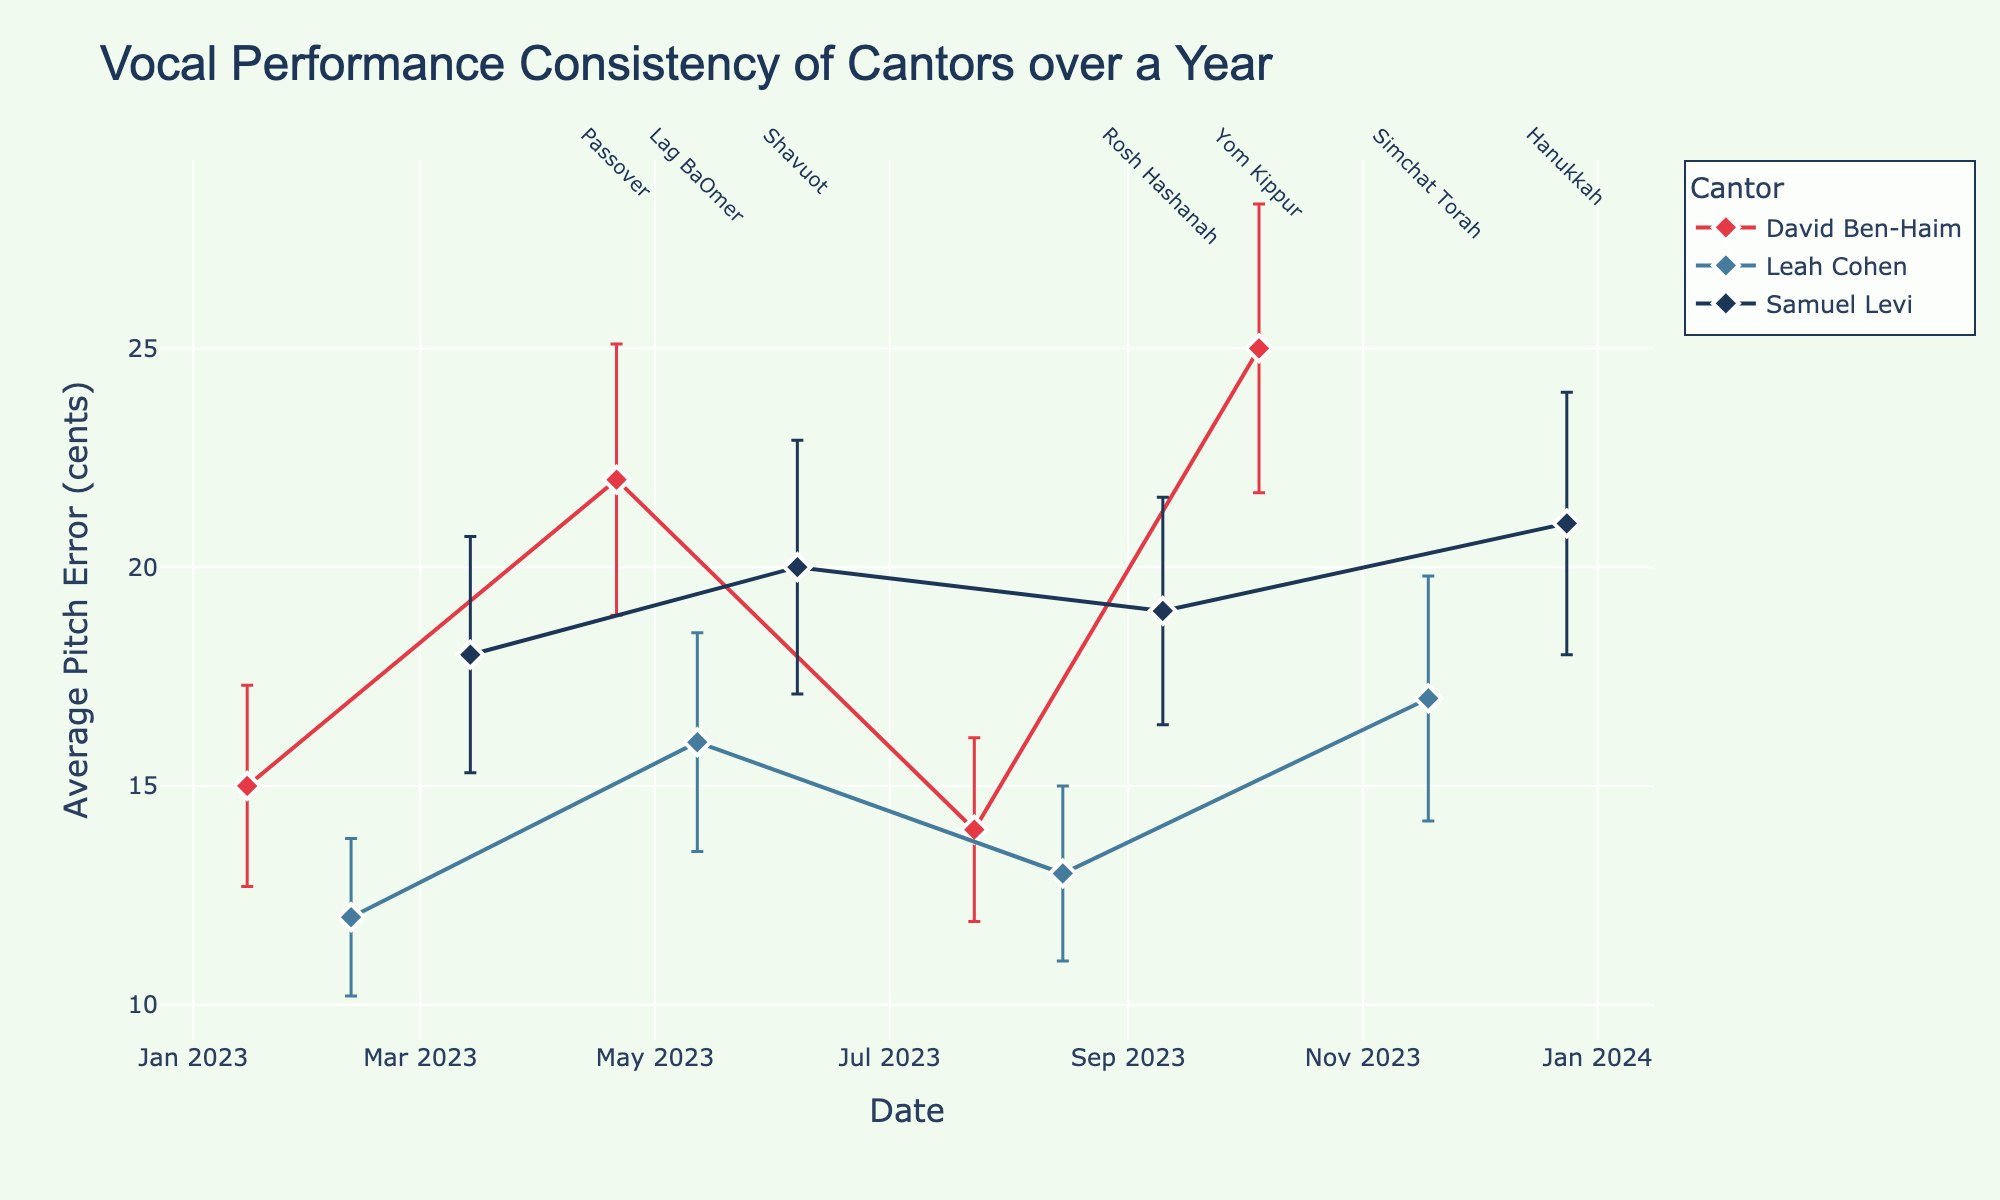How many singers are represented in the plot? The plot shows three distinct singers: David Ben-Haim, Leah Cohen, and Samuel Levi, as indicated by the legend.
Answer: 3 What is the title of the plot? The title of the plot is located at the top and reads, "Vocal Performance Consistency of Cantors over a Year".
Answer: Vocal Performance Consistency of Cantors over a Year On which date does David Ben-Haim have the highest average pitch error? By inspecting the data points for David Ben-Haim, the highest average pitch error occurs on October 5, 2023, corresponding to the Yom Kippur Service, with an average pitch error of 25 cents.
Answer: October 5, 2023 Which cantor has the most consistent (lowest standard deviation) performance at any event and on which date? Leah Cohen has the lowest standard deviation of 1.8 cents on February 11, 2023, during the Bar Mitzvah event.
Answer: Leah Cohen on February 11, 2023 What is the average pitch error of Samuel Levi at the Shavuot Service? The plot shows that Samuel Levi's average pitch error on June 7, 2023, during the Shavuot Service, is 20 cents.
Answer: 20 cents Compare David Ben-Haim's performance on January 15 and July 23. Which date shows a more consistent performance? David Ben-Haim has a lower standard deviation on July 23, 2023 (2.1) compared to January 15, 2023 (2.3), indicating a more consistent performance in July.
Answer: July 23, 2023 What range of average pitch error does Leah Cohen exhibit throughout the year? Leah Cohen's average pitch error ranges from 12 cents (minimum) on February 11, 2023, to 17 cents (maximum) on November 18, 2023.
Answer: 12 to 17 cents Which event shows the highest average pitch error overall? The Yom Kippur Service on October 5, 2023, performed by David Ben-Haim, has the highest average pitch error of 25 cents.
Answer: Yom Kippur Service Identify the major Jewish holidays annotated on the plot and list them with their corresponding dates. The annotated Jewish holidays on the plot are: - April 21, 2023: Passover - May 12, 2023: Lag BaOmer - June 7, 2023: Shavuot - September 10, 2023: Rosh Hashanah - October 5, 2023: Yom Kippur - November 18, 2023: Simchat Torah - December 24, 2023: Hanukkah
Answer: Passover (April 21), Lag BaOmer (May 12), Shavuot (June 7), Rosh Hashanah (September 10), Yom Kippur (October 5), Simchat Torah (November 18), Hanukkah (December 24) 